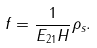Convert formula to latex. <formula><loc_0><loc_0><loc_500><loc_500>f = \frac { 1 } { E _ { 2 1 } H } \rho _ { s } .</formula> 